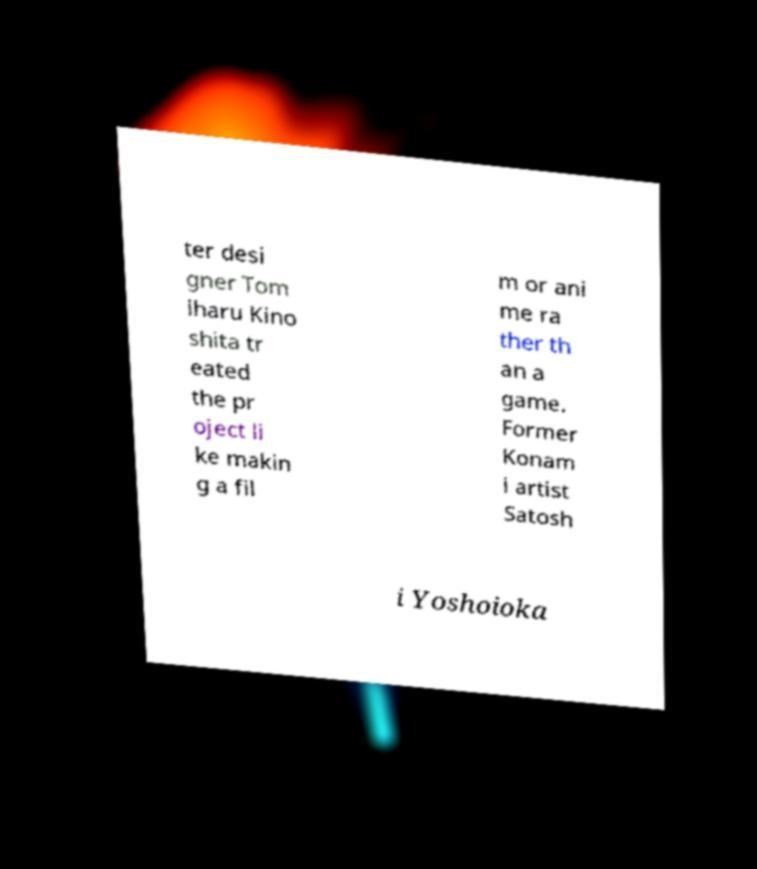Please read and relay the text visible in this image. What does it say? ter desi gner Tom iharu Kino shita tr eated the pr oject li ke makin g a fil m or ani me ra ther th an a game. Former Konam i artist Satosh i Yoshoioka 